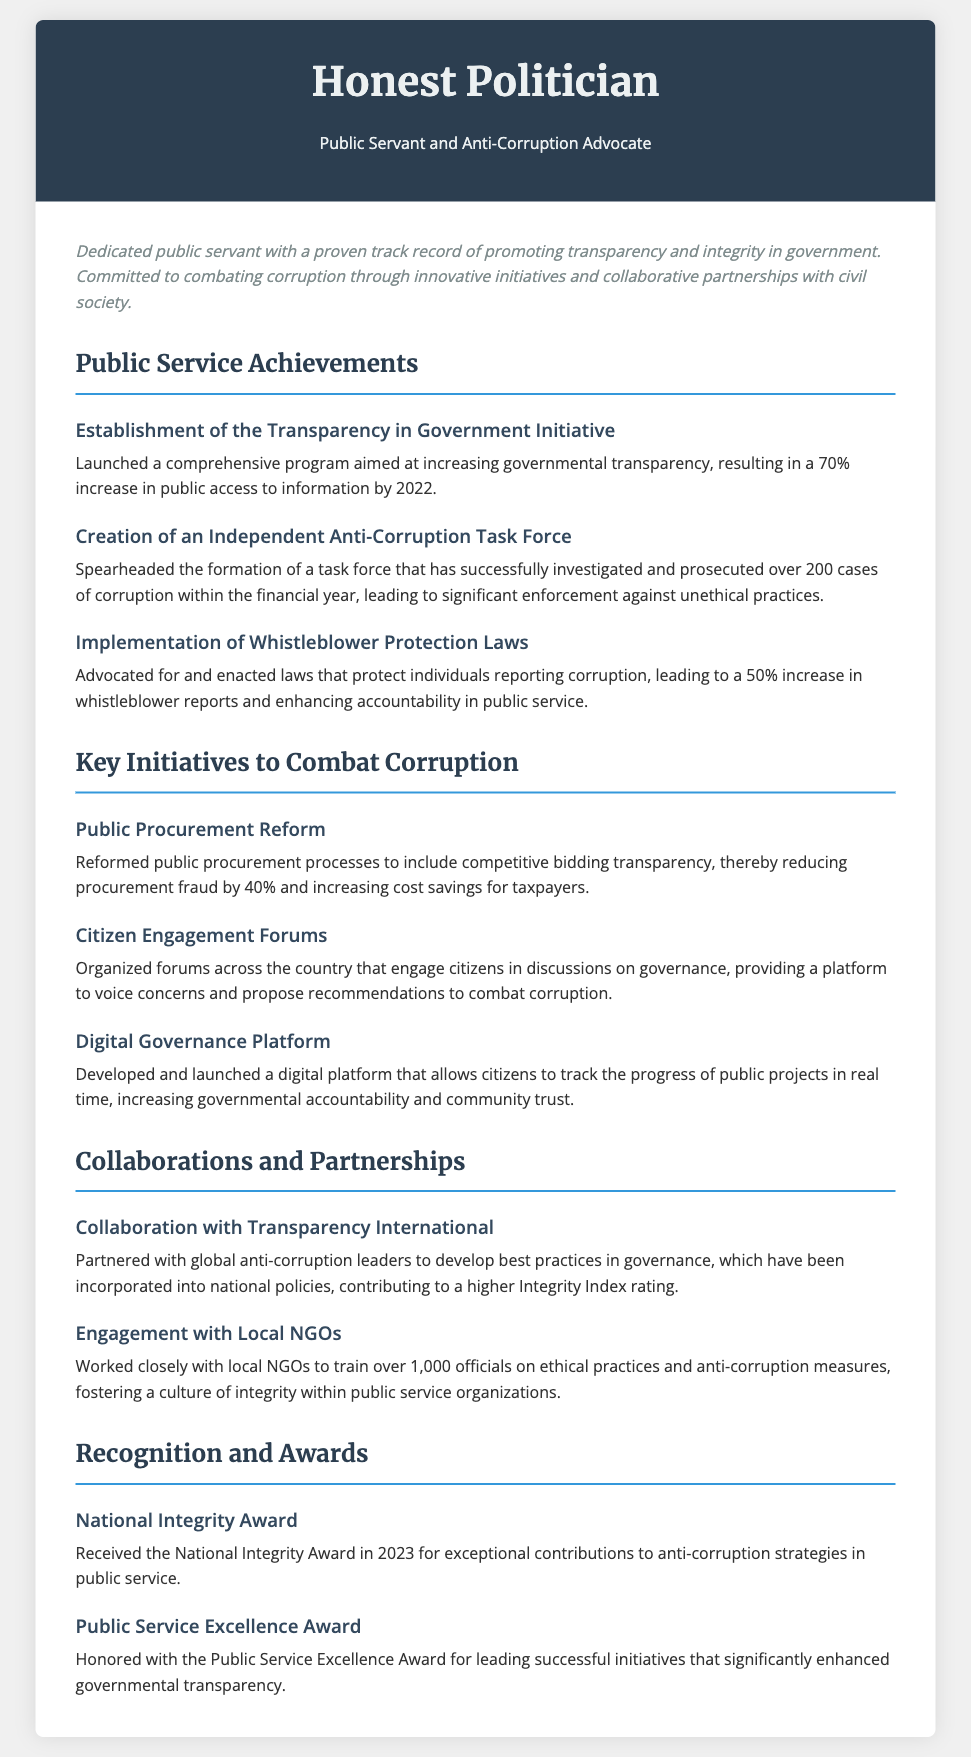What is the name of the initiative aimed at increasing governmental transparency? The initiative focused on transparency in government is explicitly titled "Transparency in Government Initiative".
Answer: Transparency in Government Initiative How many cases of corruption has the Anti-Corruption Task Force investigated and prosecuted? The document states that the task force has investigated and prosecuted over 200 cases of corruption.
Answer: 200 cases What percentage increase in whistleblower reports was achieved with the protection laws? The enactment of whistleblower protection laws led to a 50% increase in such reports.
Answer: 50% What was the reduction in procurement fraud due to public procurement reform? The reform resulted in a 40% reduction in procurement fraud.
Answer: 40% Which award was received in 2023 for contributions to anti-corruption strategies? The document mentions that the National Integrity Award was received in 2023 for these contributions.
Answer: National Integrity Award What platform was developed to allow tracking of public projects in real time? The initiative mentioned for tracking public projects is referred to as the "Digital Governance Platform".
Answer: Digital Governance Platform How many officials were trained on ethical practices by engaging with local NGOs? The document notes that over 1,000 officials have been trained by the NGOs.
Answer: 1,000 officials What organization was partnered with for developing best practices in governance? The document states a partnership with Transparency International to improve governance practices.
Answer: Transparency International 